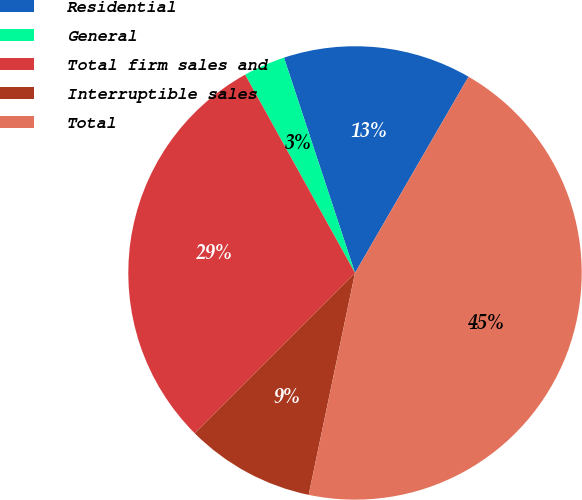<chart> <loc_0><loc_0><loc_500><loc_500><pie_chart><fcel>Residential<fcel>General<fcel>Total firm sales and<fcel>Interruptible sales<fcel>Total<nl><fcel>13.42%<fcel>2.98%<fcel>29.45%<fcel>9.22%<fcel>44.93%<nl></chart> 